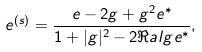<formula> <loc_0><loc_0><loc_500><loc_500>e ^ { ( s ) } = \frac { e - 2 g + g ^ { 2 } e ^ { * } } { 1 + | g | ^ { 2 } - 2 \Re a l { g e ^ { * } } } ,</formula> 